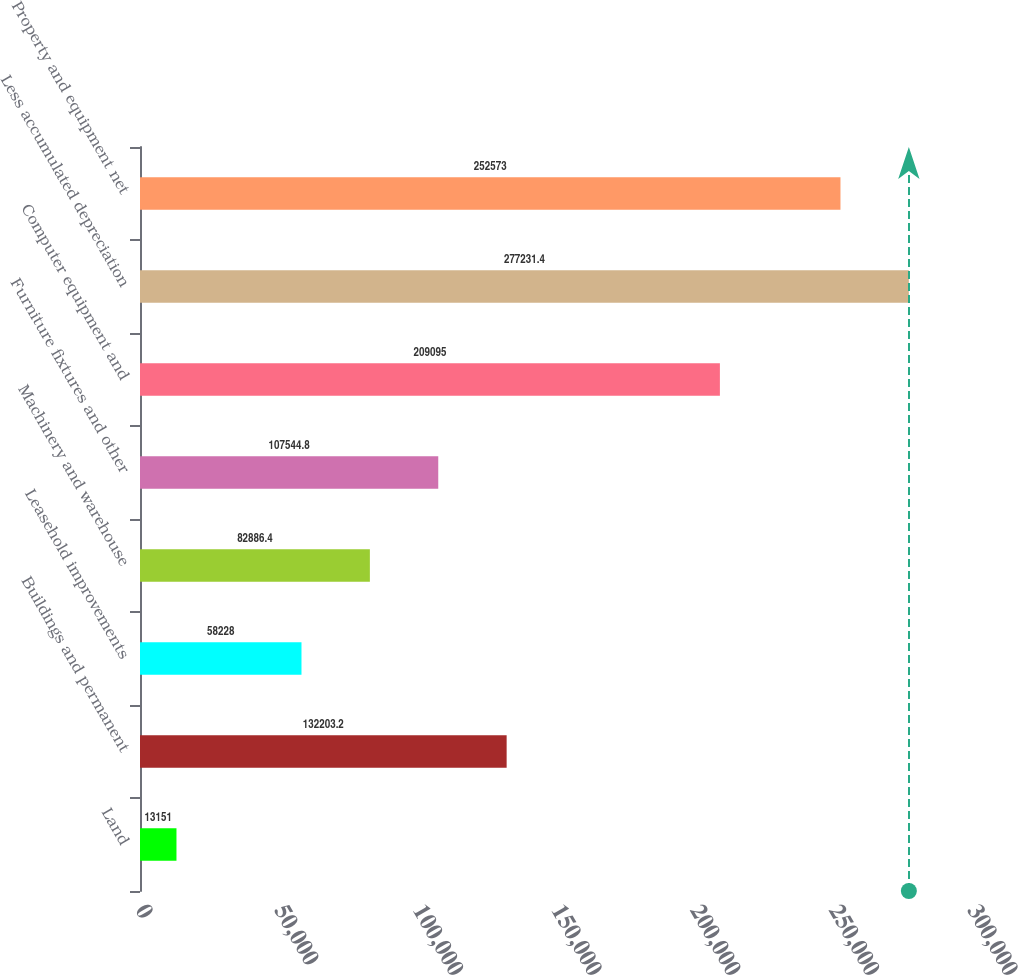Convert chart. <chart><loc_0><loc_0><loc_500><loc_500><bar_chart><fcel>Land<fcel>Buildings and permanent<fcel>Leasehold improvements<fcel>Machinery and warehouse<fcel>Furniture fixtures and other<fcel>Computer equipment and<fcel>Less accumulated depreciation<fcel>Property and equipment net<nl><fcel>13151<fcel>132203<fcel>58228<fcel>82886.4<fcel>107545<fcel>209095<fcel>277231<fcel>252573<nl></chart> 